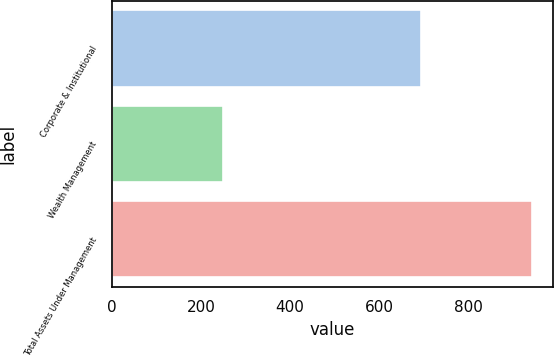Convert chart to OTSL. <chart><loc_0><loc_0><loc_500><loc_500><bar_chart><fcel>Corporate & Institutional<fcel>Wealth Management<fcel>Total Assets Under Management<nl><fcel>694<fcel>248.4<fcel>942.4<nl></chart> 